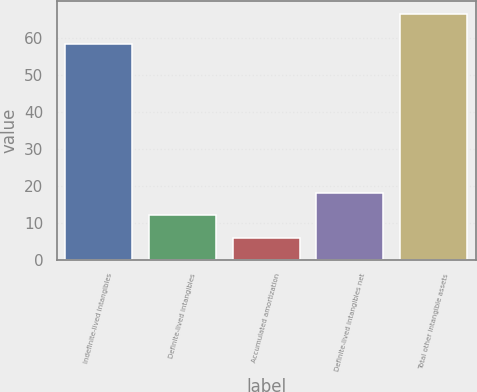<chart> <loc_0><loc_0><loc_500><loc_500><bar_chart><fcel>Indefinite-lived intangibles<fcel>Definite-lived intangibles<fcel>Accumulated amortization<fcel>Definite-lived intangibles net<fcel>Total other intangible assets<nl><fcel>58.3<fcel>11.97<fcel>5.9<fcel>18.04<fcel>66.6<nl></chart> 